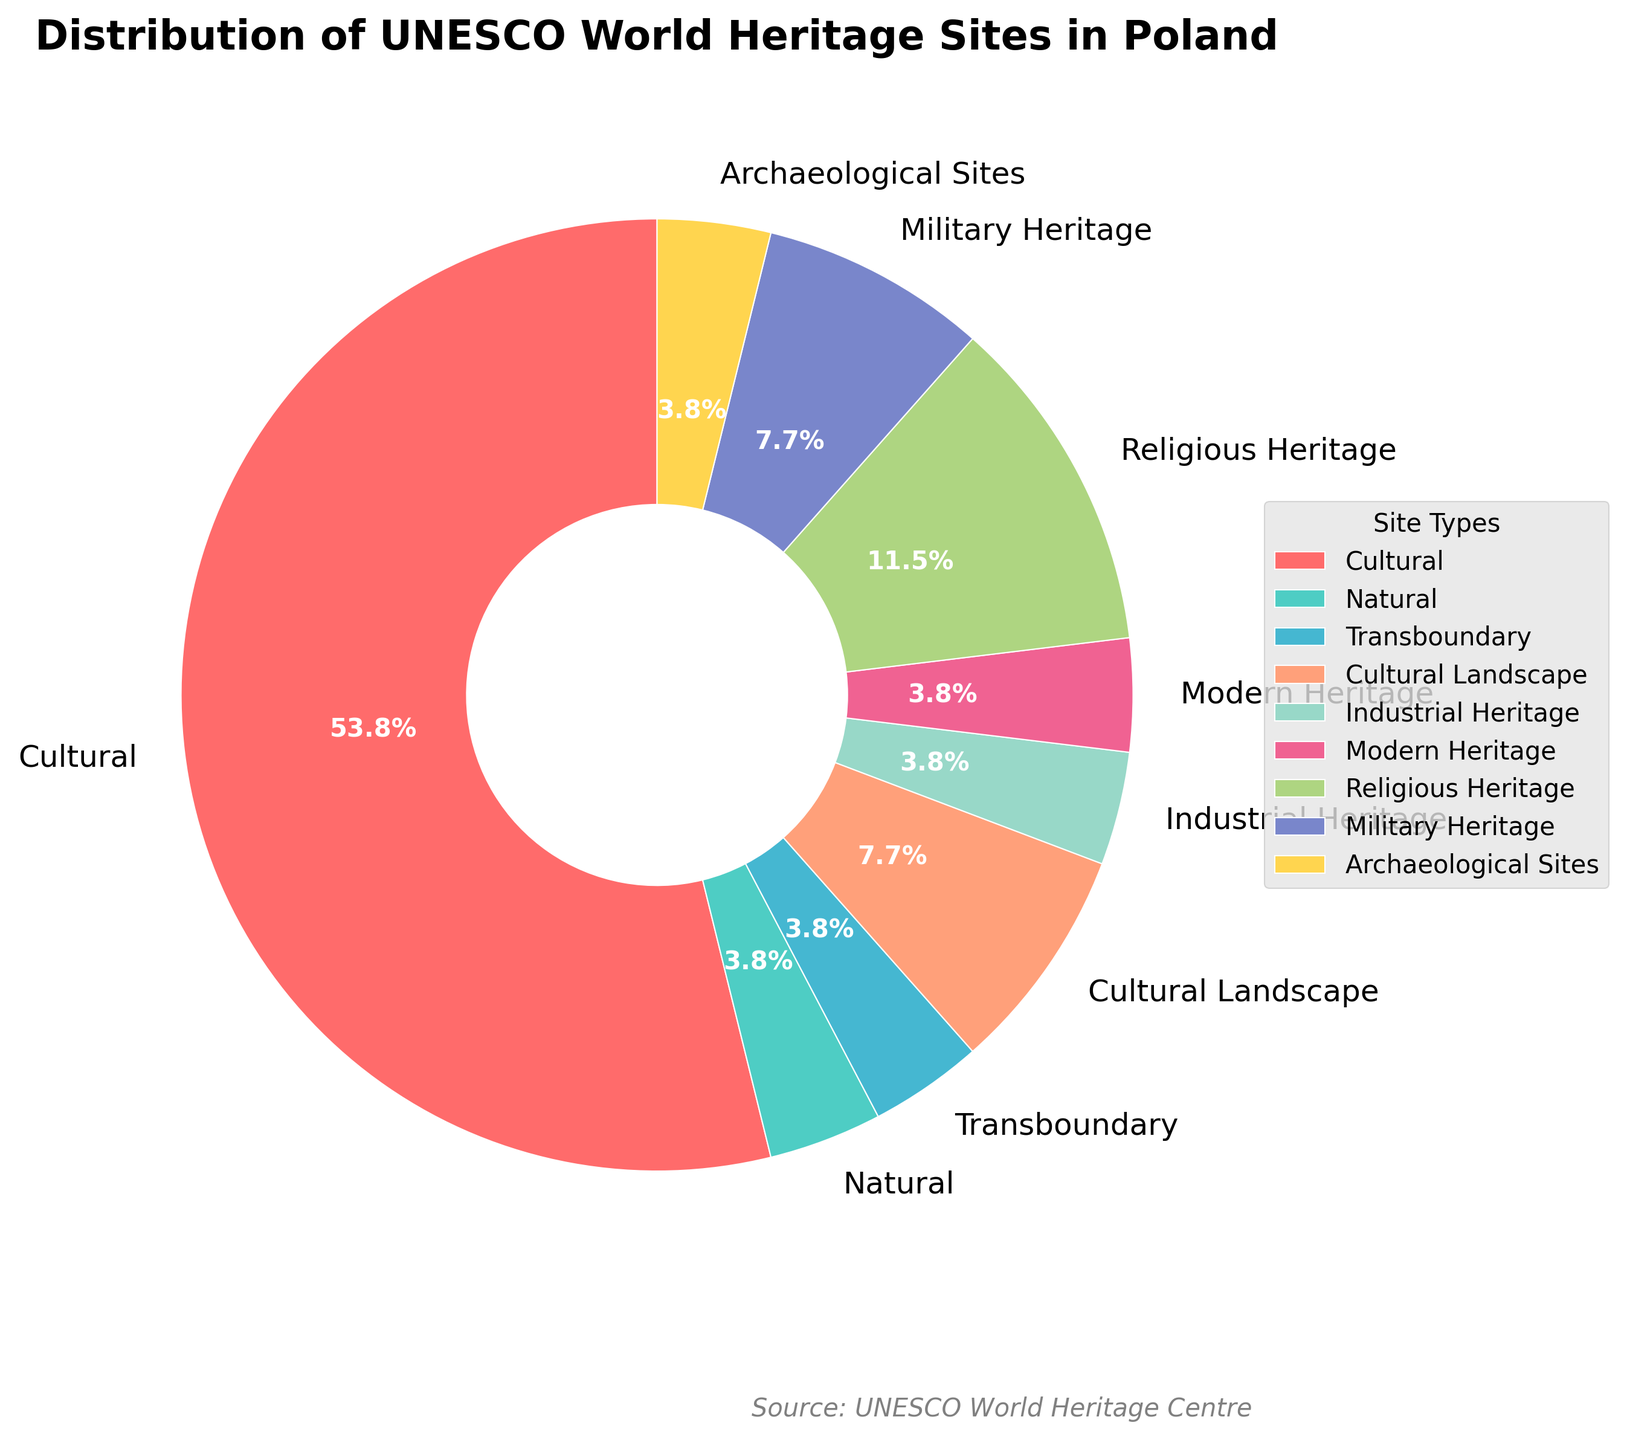What percentage of the UNESCO World Heritage Sites in Poland are Cultural sites? Cultural sites occupy 14 out of a total of 26 sites. The percentage is calculated as (14/26) * 100 ≈ 53.8%.
Answer: 53.8% How many more Cultural sites are there compared to Natural sites? Cultural sites are 14, and Natural sites are 1. The difference is 14 - 1 = 13.
Answer: 13 Which types of sites have an equal number? Military Heritage and Cultural Landscape both have 2 sites each.
Answer: Military Heritage and Cultural Landscape What is the combined percentage of Transboundary and Industrial Heritage sites? Transboundary has 1 site and Industrial Heritage has 1 site each. Combined, they have 2 out of 26 sites, translating to (2/26) * 100 ≈ 7.7%.
Answer: 7.7% Among the types listed, which one has the least number of sites? Both Mixed and Archaeological Sites have the least number, with only 1 site each.
Answer: Mixed and Archaeological Sites Which type of heritage site is represented by the green color on the pie chart? The green color (light turquoise) represents Transboundary sites on the pie chart.
Answer: Transboundary What is the total number of sites that can be categorized as "Heritage" (Industrial, Modern, Religious, Military)? Summing Industrial Heritage (1), Modern Heritage (1), Religious Heritage (3), and Military Heritage (2), we get 1 + 1 + 3 + 2 = 7.
Answer: 7 How much higher is the percentage of Religious Heritage sites compared to Natural sites? Religious Heritage sites have 3 out of 26 sites, translating to (3/26) * 100 ≈ 11.5%. Natural sites have (1/26) * 100 ≈ 3.8%. The difference is 11.5% - 3.8% ≈ 7.7%.
Answer: 7.7% Which types of sites collectively make up over 50% of the UNESCO World Heritage Sites in Poland? Cultural sites make up 53.8% alone, which is over 50%.
Answer: Cultural Sites 